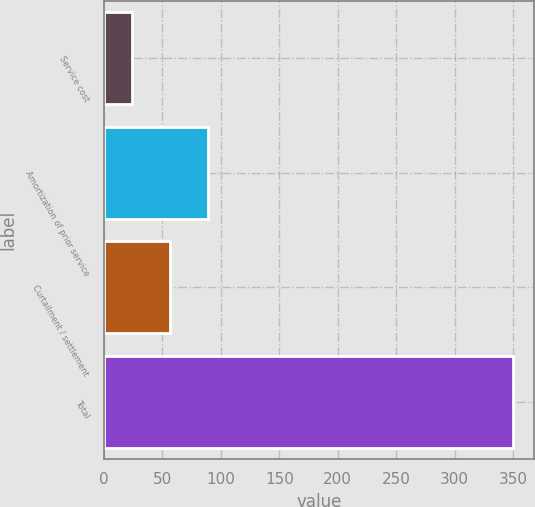Convert chart. <chart><loc_0><loc_0><loc_500><loc_500><bar_chart><fcel>Service cost<fcel>Amortization of prior service<fcel>Curtailment / settlement<fcel>Total<nl><fcel>24<fcel>89.2<fcel>56.6<fcel>350<nl></chart> 